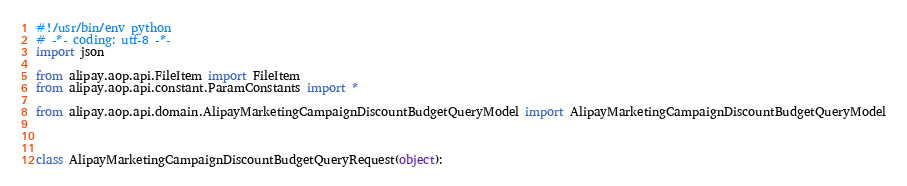Convert code to text. <code><loc_0><loc_0><loc_500><loc_500><_Python_>#!/usr/bin/env python
# -*- coding: utf-8 -*-
import json

from alipay.aop.api.FileItem import FileItem
from alipay.aop.api.constant.ParamConstants import *

from alipay.aop.api.domain.AlipayMarketingCampaignDiscountBudgetQueryModel import AlipayMarketingCampaignDiscountBudgetQueryModel



class AlipayMarketingCampaignDiscountBudgetQueryRequest(object):
</code> 